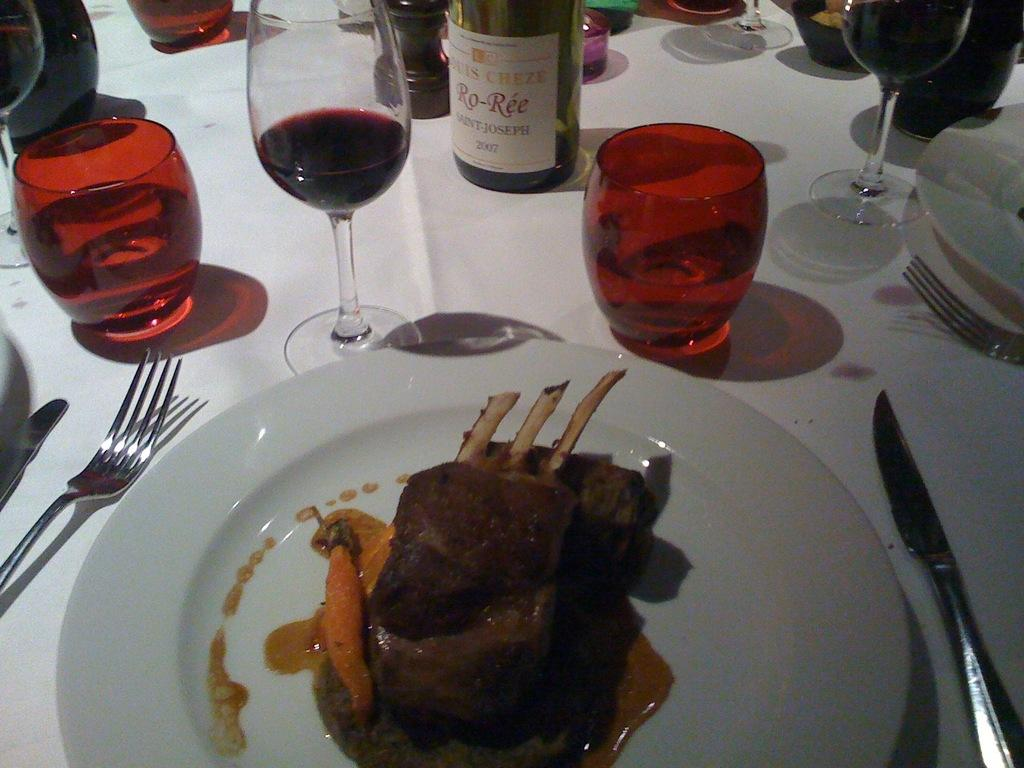What piece of furniture is present in the image? There is a table in the image. What is placed on the table? There is food on a plate on the table. What else can be seen on the table? There are glasses with drinks in the image. Is there any other related item near the glasses? Yes, there is a bottle beside the glasses. How many pets are sitting on the table in the image? There are no pets present in the image; it only features a table, food on a plate, glasses with drinks, and a bottle. What type of lunch is being served on the table in the image? The image does not specify the type of food being served on the plate, so it cannot be determined if it is lunch or not. 